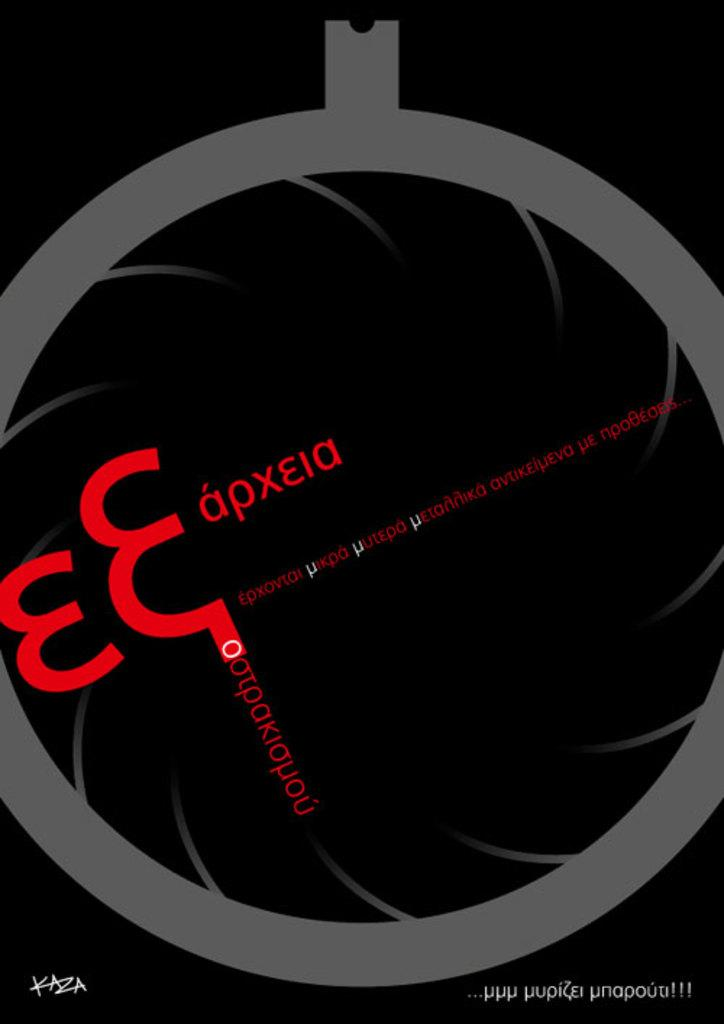<image>
Relay a brief, clear account of the picture shown. a black poster with greek writing like Eapxeia 